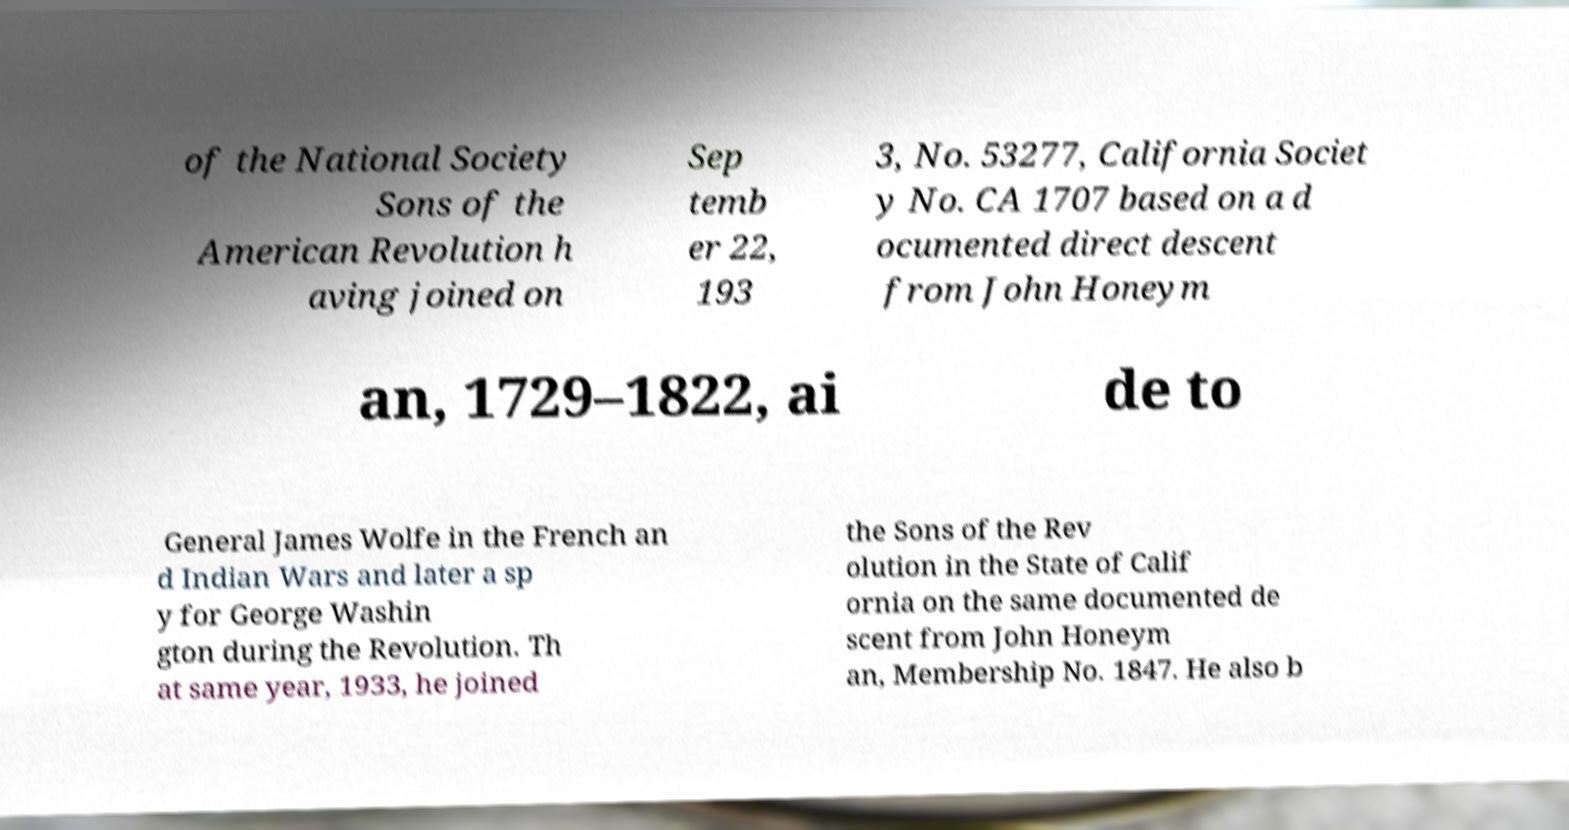Please identify and transcribe the text found in this image. of the National Society Sons of the American Revolution h aving joined on Sep temb er 22, 193 3, No. 53277, California Societ y No. CA 1707 based on a d ocumented direct descent from John Honeym an, 1729–1822, ai de to General James Wolfe in the French an d Indian Wars and later a sp y for George Washin gton during the Revolution. Th at same year, 1933, he joined the Sons of the Rev olution in the State of Calif ornia on the same documented de scent from John Honeym an, Membership No. 1847. He also b 